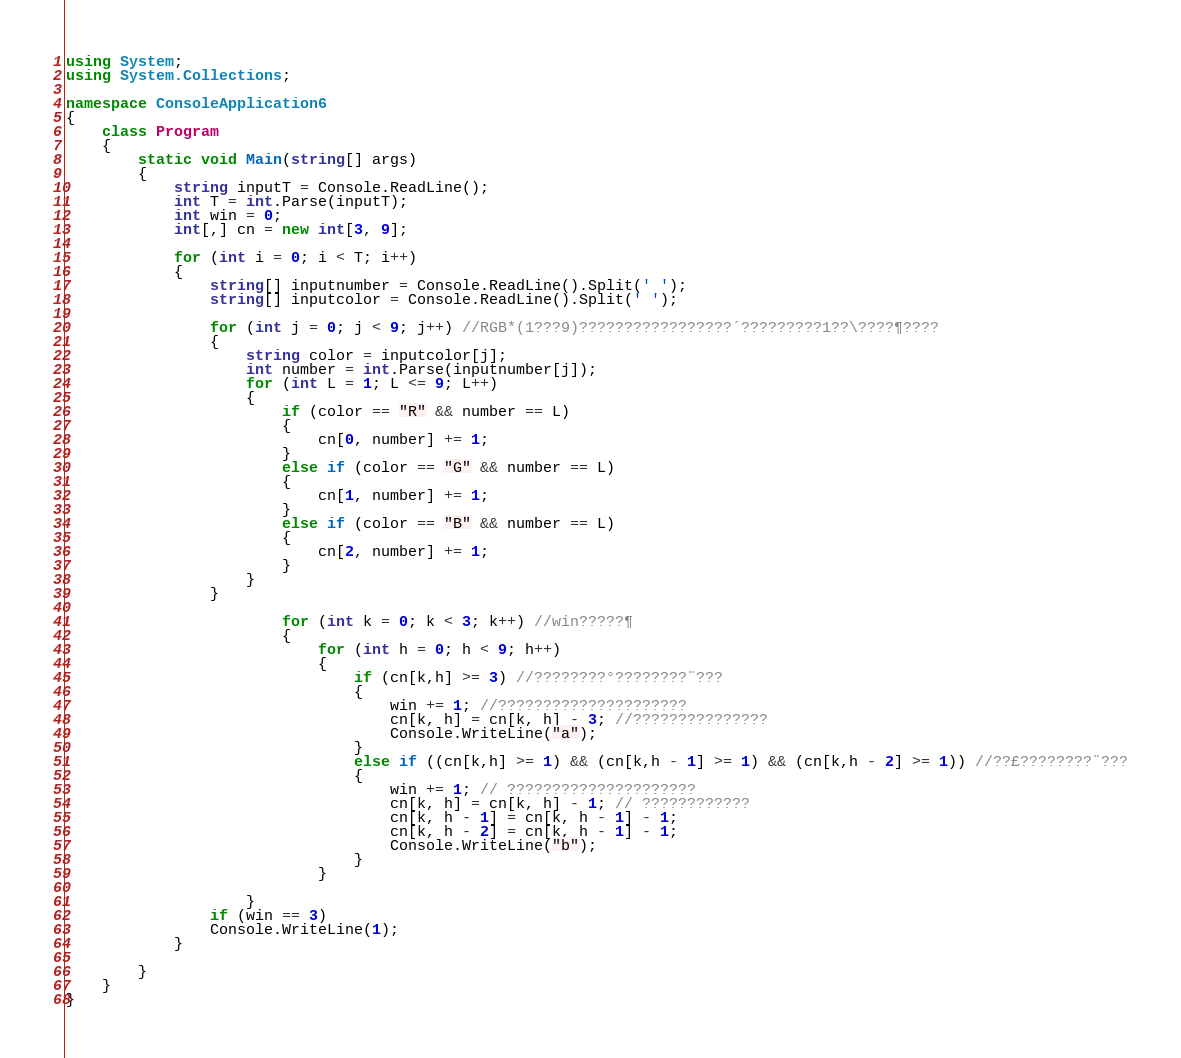Convert code to text. <code><loc_0><loc_0><loc_500><loc_500><_C#_>using System;
using System.Collections;

namespace ConsoleApplication6
{
    class Program
    {
        static void Main(string[] args)
        {
            string inputT = Console.ReadLine();
            int T = int.Parse(inputT);
            int win = 0;
            int[,] cn = new int[3, 9];

            for (int i = 0; i < T; i++)
            {
                string[] inputnumber = Console.ReadLine().Split(' ');
                string[] inputcolor = Console.ReadLine().Split(' ');

                for (int j = 0; j < 9; j++) //RGB*(1???9)?????????????????´?????????1??\????¶????
                {
                    string color = inputcolor[j];
                    int number = int.Parse(inputnumber[j]);
                    for (int L = 1; L <= 9; L++)
                    {
                        if (color == "R" && number == L)
                        {
                            cn[0, number] += 1;
                        }
                        else if (color == "G" && number == L)
                        {
                            cn[1, number] += 1;
                        }
                        else if (color == "B" && number == L)
                        {
                            cn[2, number] += 1;
                        }
                    }
                }

                        for (int k = 0; k < 3; k++) //win?????¶
                        {
                            for (int h = 0; h < 9; h++)
                            {
                                if (cn[k,h] >= 3) //????????°????????¨???
                                {
                                    win += 1; //?????????????????????
                                    cn[k, h] = cn[k, h] - 3; //???????????????
                                    Console.WriteLine("a");
                                }
                                else if ((cn[k,h] >= 1) && (cn[k,h - 1] >= 1) && (cn[k,h - 2] >= 1)) //??£????????¨???
                                {
                                    win += 1; // ?????????????????????
                                    cn[k, h] = cn[k, h] - 1; // ????????????
                                    cn[k, h - 1] = cn[k, h - 1] - 1;
                                    cn[k, h - 2] = cn[k, h - 1] - 1;
                                    Console.WriteLine("b");
                                }
                            }

                    }
                if (win == 3)
                Console.WriteLine(1);
            }

        }
    }
}</code> 